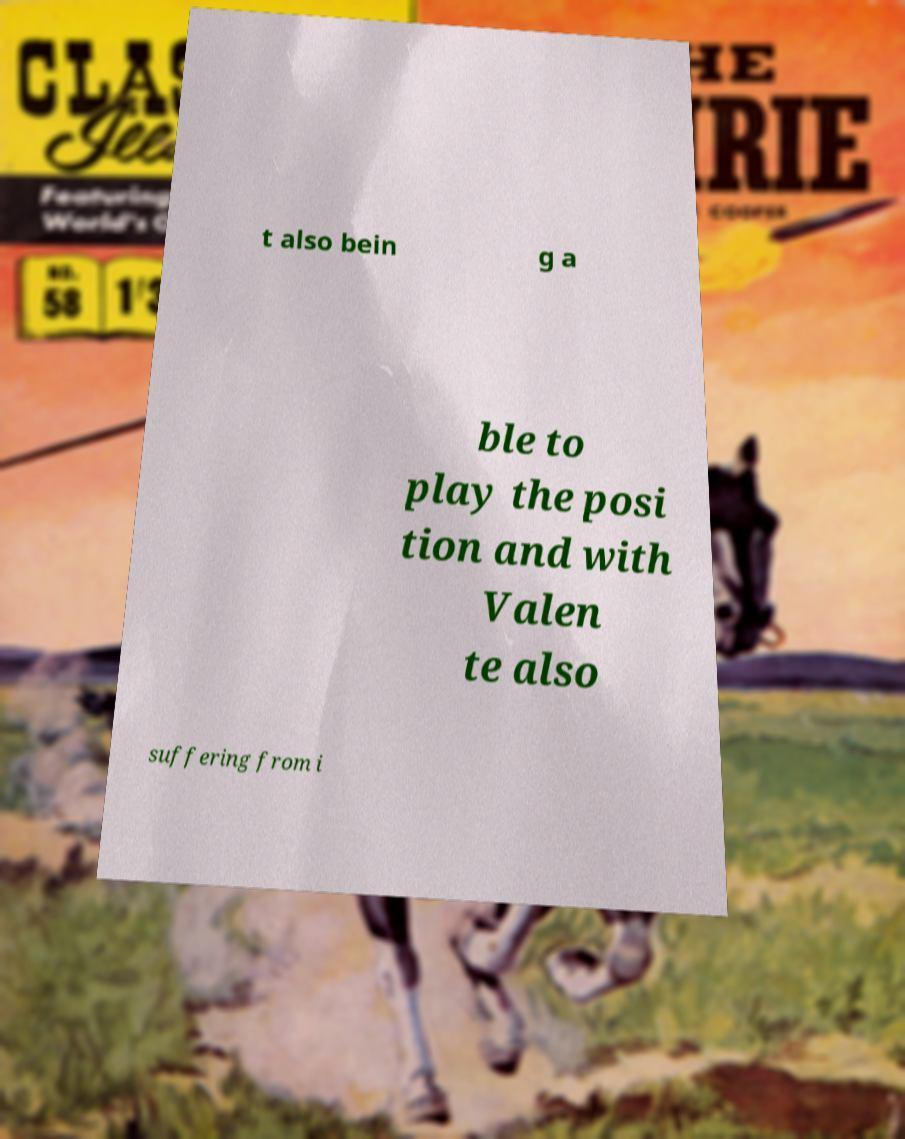Please read and relay the text visible in this image. What does it say? t also bein g a ble to play the posi tion and with Valen te also suffering from i 